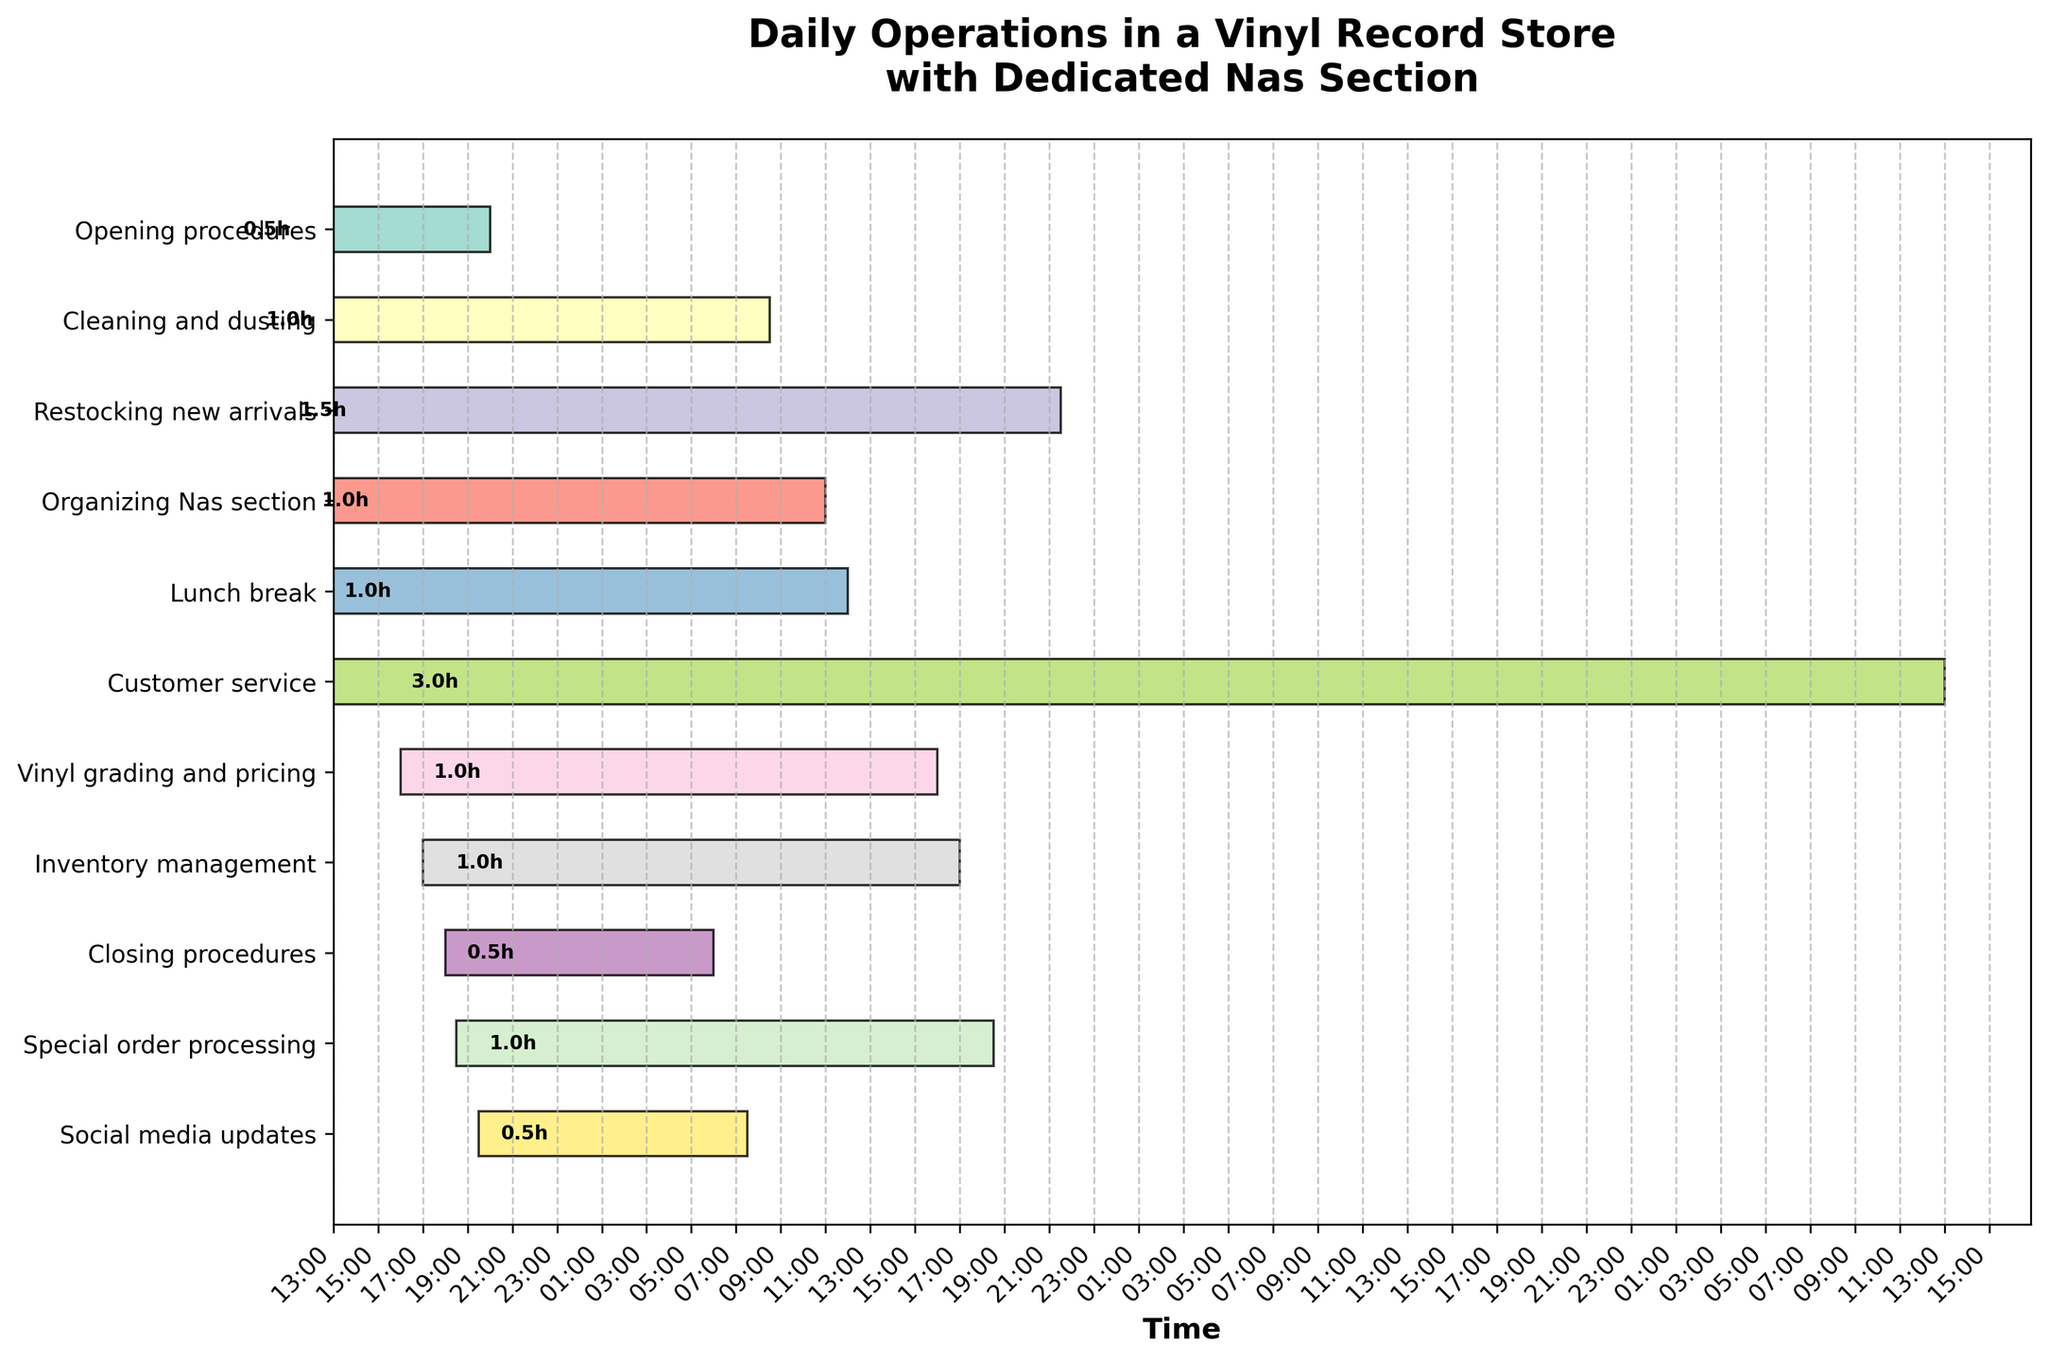What is the task that starts at 11:00? Look at the y-axis labels and match the start times to find the task.
Answer: Organizing Nas section How long does the "Customer service" task last? Find the "Customer service" task on the y-axis and check the duration mentioned next to it.
Answer: 3 hours Which task is performed immediately after "Restocking new arrivals"? Identify the end time of "Restocking new arrivals" and match it with the next task’s start time on the y-axis labels.
Answer: Organizing Nas section How much total time is allocated to cleaning-related activities? Identify tasks related to cleaning (Cleaning and dusting), and sum up their durations. 1 hour from "Cleaning and dusting".
Answer: 1 hour What is the cumulative duration for all activities starting before noon? Sum the durations of all tasks starting before 12:00 (Opening procedures, Cleaning and dusting, Restocking new arrivals, Organizing Nas section, Lunch break).
Answer: 5 hours Which task ends the latest, and at what time? Look for the task that ends the latest by checking the end times of all tasks.
Answer: Social media updates, 20:00 Is there any overlap between "Inventory management" and "Closing procedures"? Compare the end time of "Inventory management" with the start time of "Closing procedures". No, "Inventory management" ends at 18:00 and "Closing procedures" start at 18:00.
Answer: No How does the duration of "Vinyl grading and pricing" compare with "Inventory management"? Check the durations of both tasks and compare them. Both have 1-hour durations.
Answer: They are equal Which tasks have the shortest duration, and how long is it? Identifying the tasks with the shortest duration by looking at each task's duration. Both "Opening procedures," "Closing procedures," and "Social media updates" last 0.5 hours.
Answer: Opening procedures, Closing procedures, Social media updates, 0.5 hour In total, how much time is spent from "Opening procedures" to "Special order processing"? Calculate the total duration from 08:00 to the end of "Special order processing" at 19:30 by finding the difference in hours.
Answer: 11.5 hours 